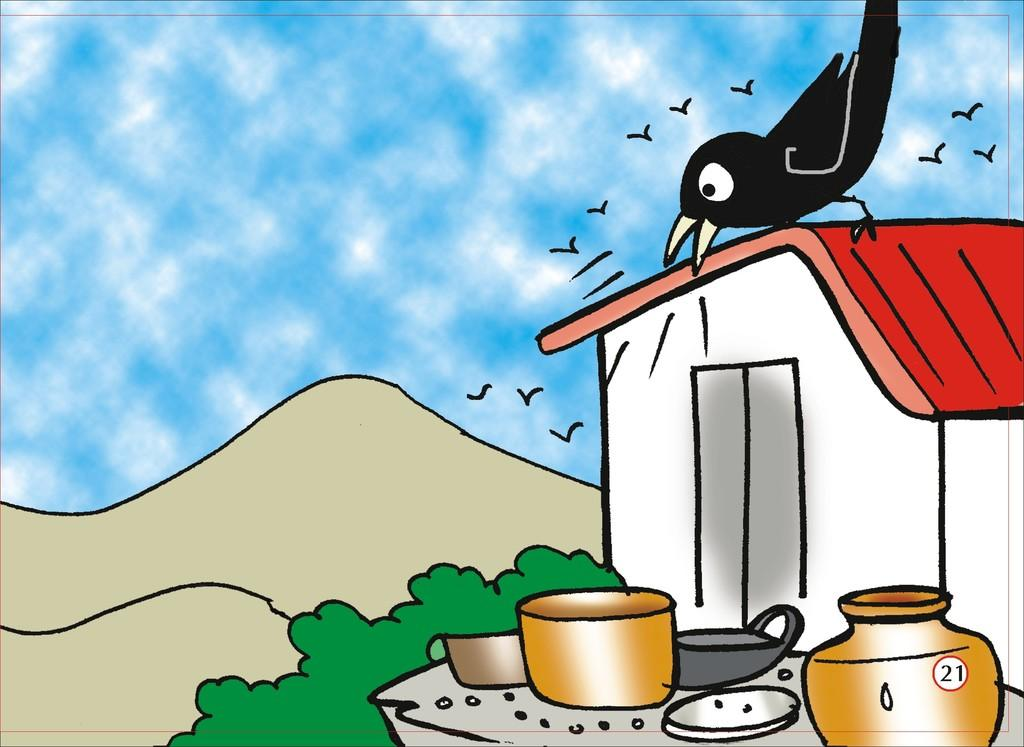What type of animals are depicted in the drawings in the image? There are drawings of birds in the image. What type of structure is depicted in the drawings in the image? There is a drawing of a house in the image. What type of natural elements are depicted in the drawings in the image? There are drawings of plants and mountains in the image. What type of weather is depicted in the drawings in the image? There is a drawing of a cloudy sky in the image. What other types of objects are depicted in the drawings in the image? There are drawings of various objects in the image. What color is the wall behind the drawings in the image? There is no wall visible in the image; it is a collection of drawings. How does the temper of the artist affect the drawings in the image? The temper of the artist is not mentioned or depicted in the image, so it cannot be determined how it might affect the drawings. 